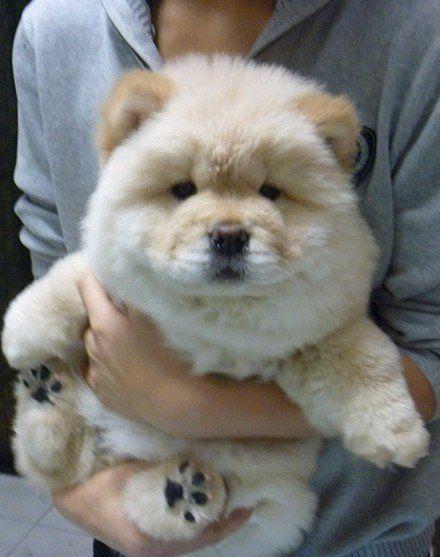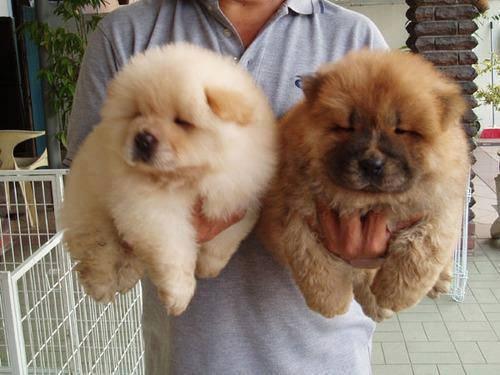The first image is the image on the left, the second image is the image on the right. Given the left and right images, does the statement "There is exactly one dog in the right image." hold true? Answer yes or no. No. The first image is the image on the left, the second image is the image on the right. Examine the images to the left and right. Is the description "A chow dog with its blue tongue showing is standing on all fours with its body in profile." accurate? Answer yes or no. No. 